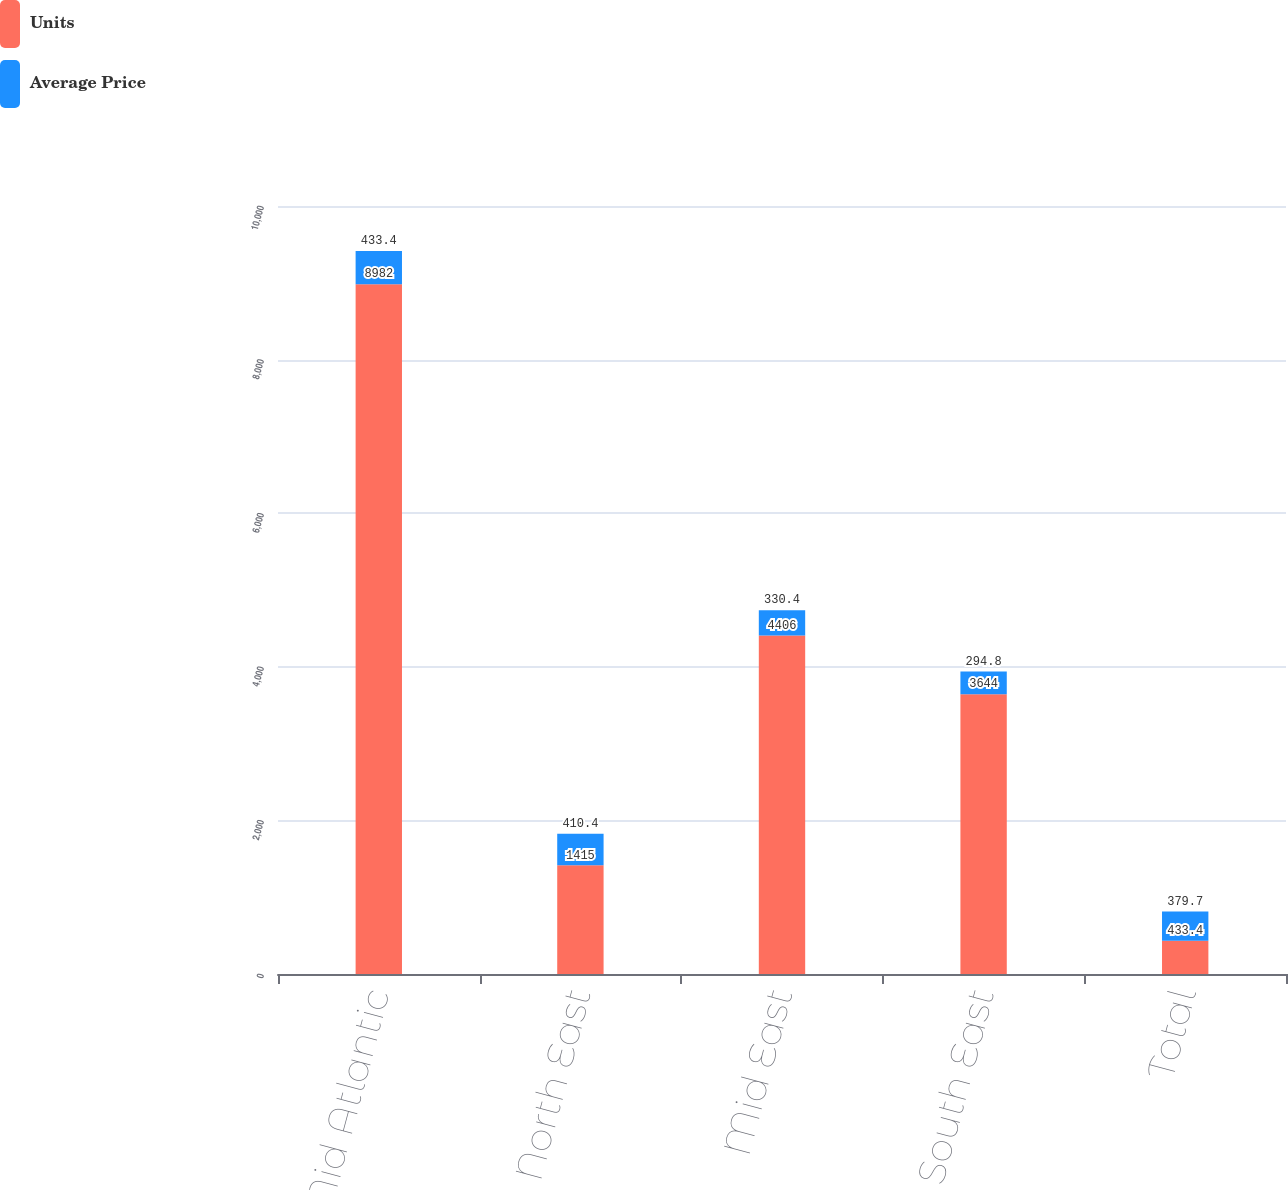Convert chart to OTSL. <chart><loc_0><loc_0><loc_500><loc_500><stacked_bar_chart><ecel><fcel>Mid Atlantic<fcel>North East<fcel>Mid East<fcel>South East<fcel>Total<nl><fcel>Units<fcel>8982<fcel>1415<fcel>4406<fcel>3644<fcel>433.4<nl><fcel>Average Price<fcel>433.4<fcel>410.4<fcel>330.4<fcel>294.8<fcel>379.7<nl></chart> 